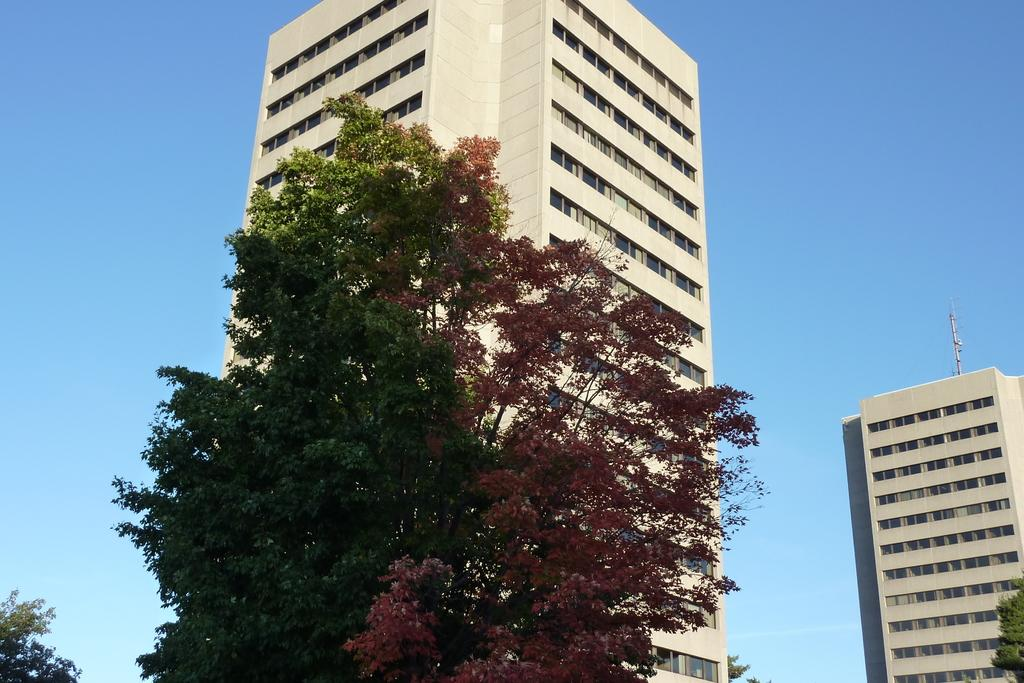What type of structures can be seen in the image? There are buildings in the image. What other natural elements are present in the image? There are trees in the image. What can be seen in the distance in the image? The sky is visible in the background of the image. What type of bread is being used to paint the buildings in the image? There is no bread or painting activity present in the image; it features buildings, trees, and the sky. 